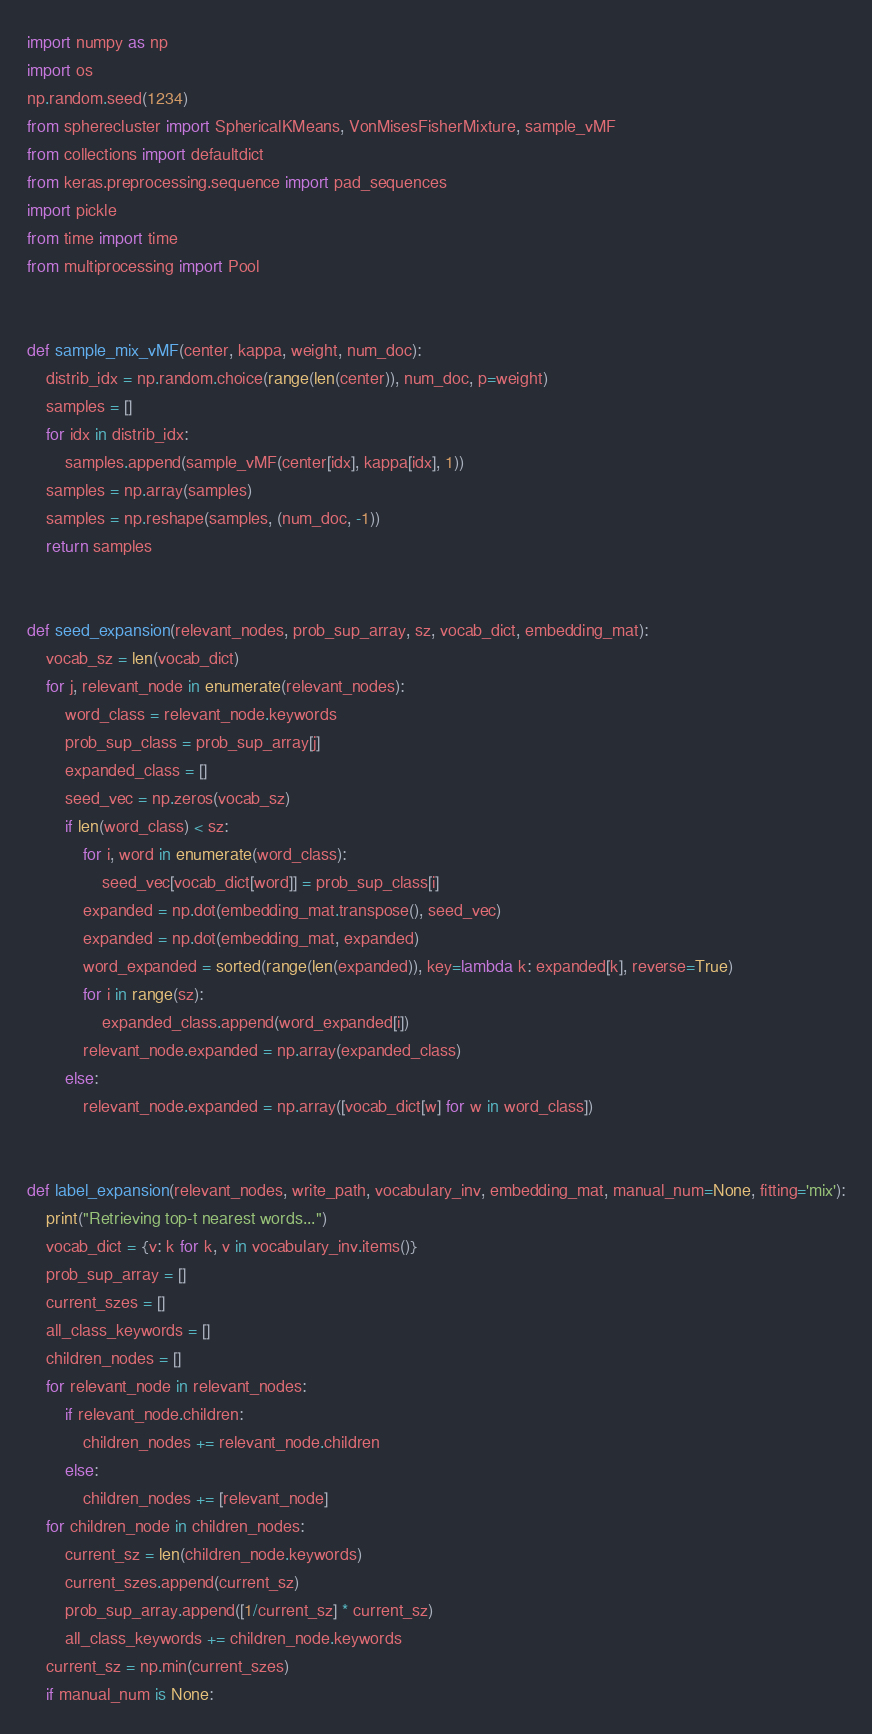Convert code to text. <code><loc_0><loc_0><loc_500><loc_500><_Python_>import numpy as np
import os
np.random.seed(1234)
from spherecluster import SphericalKMeans, VonMisesFisherMixture, sample_vMF
from collections import defaultdict
from keras.preprocessing.sequence import pad_sequences
import pickle
from time import time
from multiprocessing import Pool


def sample_mix_vMF(center, kappa, weight, num_doc):
    distrib_idx = np.random.choice(range(len(center)), num_doc, p=weight)
    samples = []
    for idx in distrib_idx:
        samples.append(sample_vMF(center[idx], kappa[idx], 1))
    samples = np.array(samples)
    samples = np.reshape(samples, (num_doc, -1))
    return samples


def seed_expansion(relevant_nodes, prob_sup_array, sz, vocab_dict, embedding_mat):
    vocab_sz = len(vocab_dict)
    for j, relevant_node in enumerate(relevant_nodes):
        word_class = relevant_node.keywords
        prob_sup_class = prob_sup_array[j]
        expanded_class = []
        seed_vec = np.zeros(vocab_sz)
        if len(word_class) < sz:
            for i, word in enumerate(word_class):
                seed_vec[vocab_dict[word]] = prob_sup_class[i]
            expanded = np.dot(embedding_mat.transpose(), seed_vec)
            expanded = np.dot(embedding_mat, expanded)
            word_expanded = sorted(range(len(expanded)), key=lambda k: expanded[k], reverse=True)
            for i in range(sz):
                expanded_class.append(word_expanded[i])
            relevant_node.expanded = np.array(expanded_class)
        else:
            relevant_node.expanded = np.array([vocab_dict[w] for w in word_class])


def label_expansion(relevant_nodes, write_path, vocabulary_inv, embedding_mat, manual_num=None, fitting='mix'):
    print("Retrieving top-t nearest words...")
    vocab_dict = {v: k for k, v in vocabulary_inv.items()}
    prob_sup_array = []
    current_szes = []
    all_class_keywords = []
    children_nodes = []
    for relevant_node in relevant_nodes:
        if relevant_node.children:
            children_nodes += relevant_node.children
        else:
            children_nodes += [relevant_node]
    for children_node in children_nodes:
        current_sz = len(children_node.keywords)
        current_szes.append(current_sz)
        prob_sup_array.append([1/current_sz] * current_sz)
        all_class_keywords += children_node.keywords
    current_sz = np.min(current_szes)
    if manual_num is None:</code> 